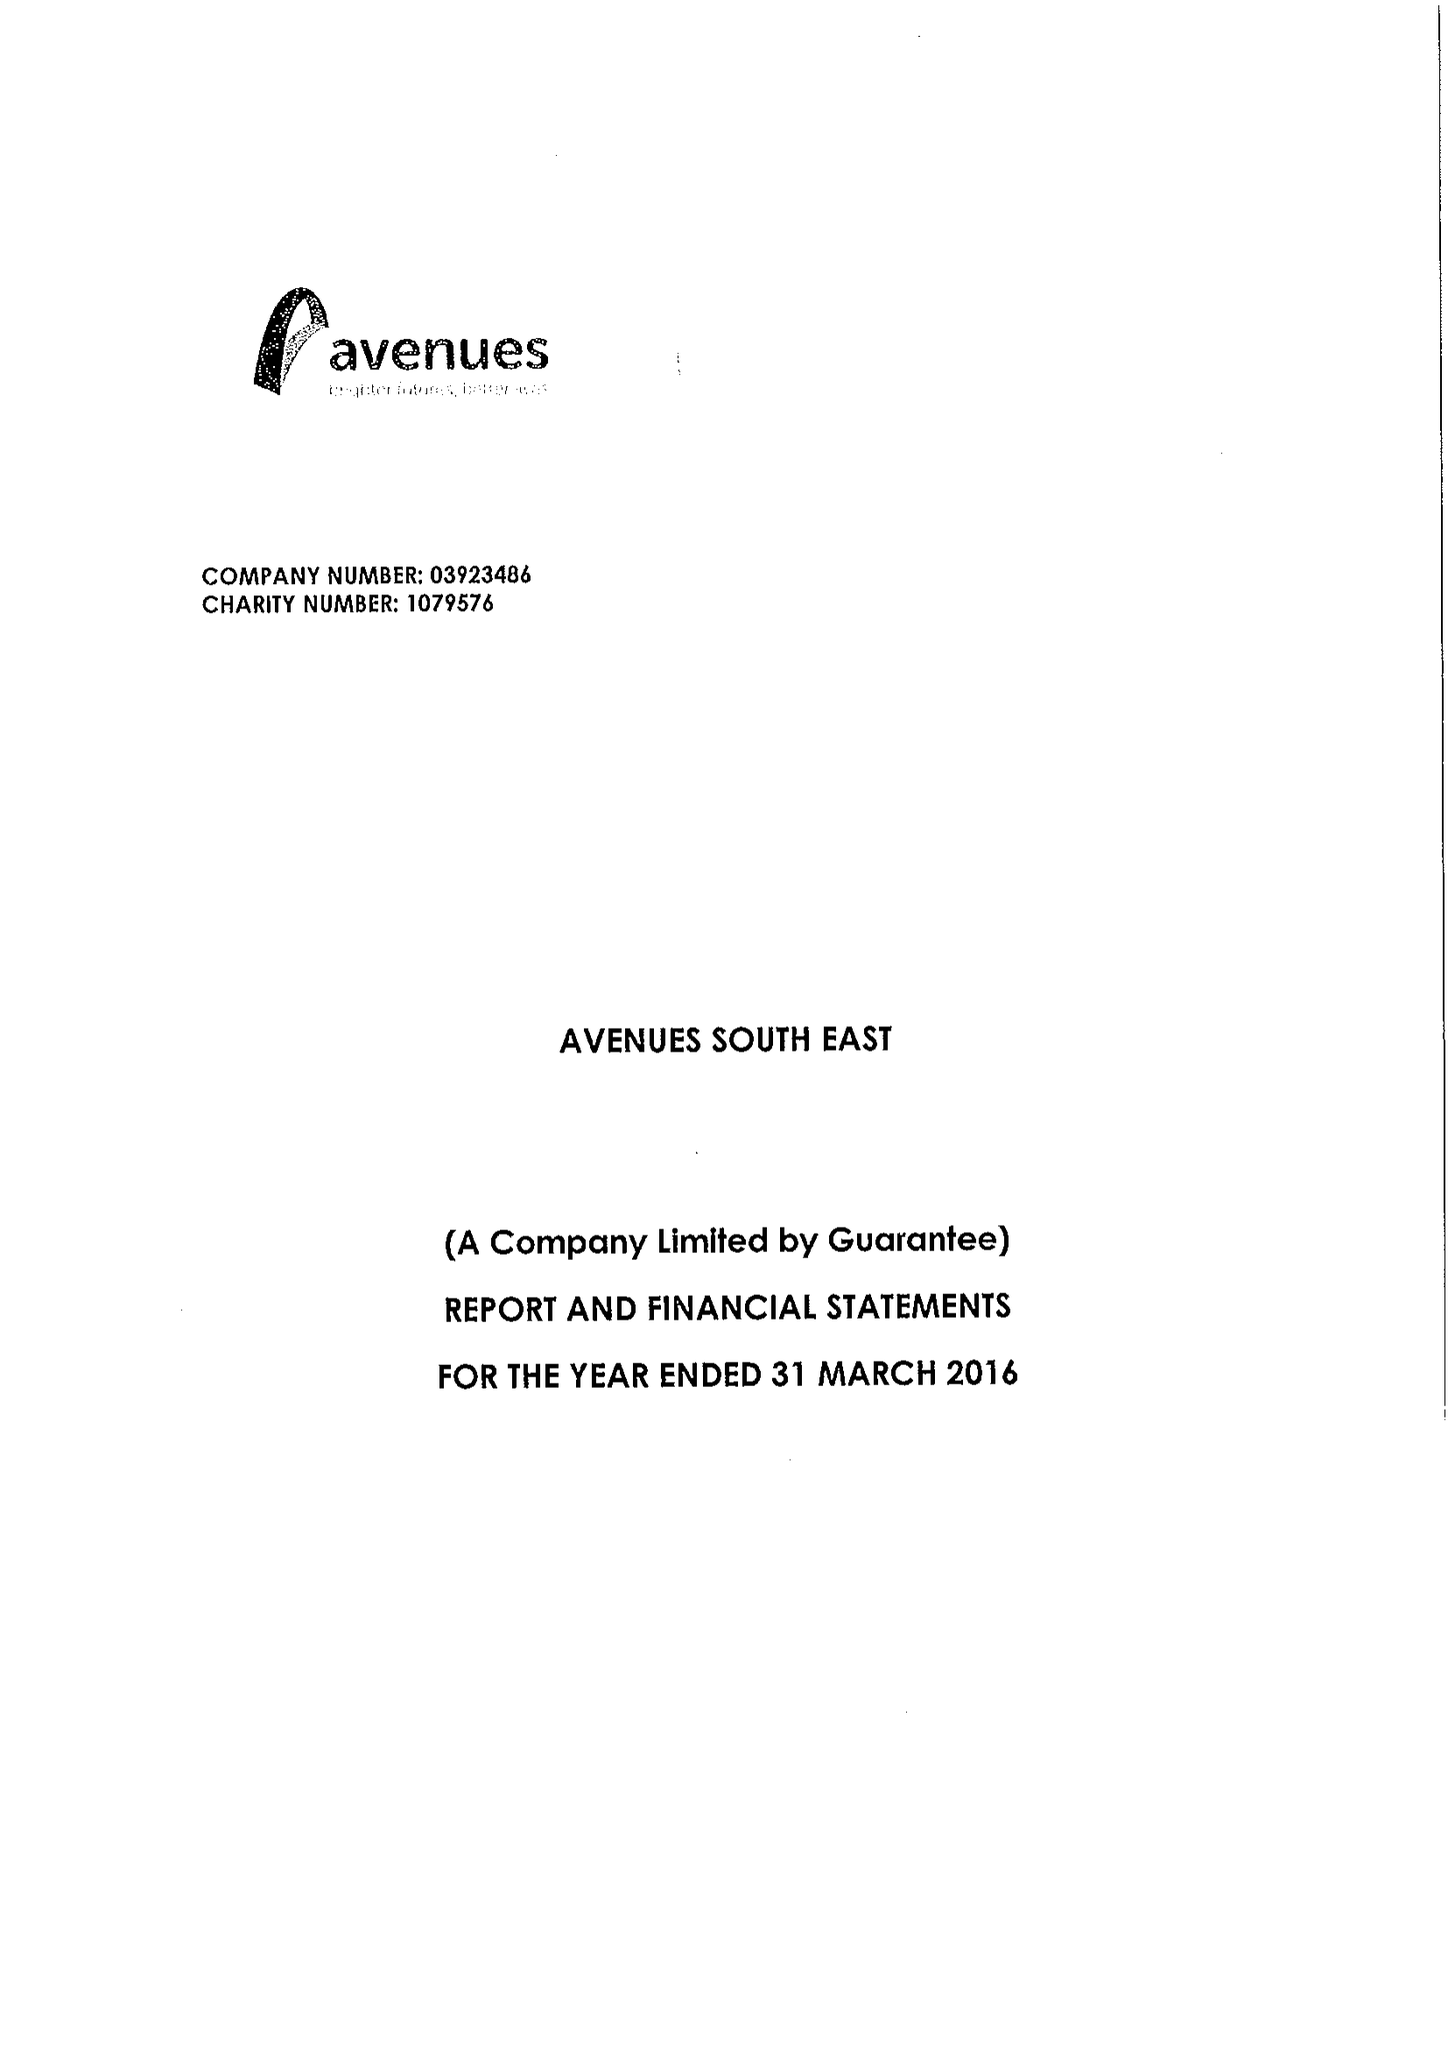What is the value for the charity_number?
Answer the question using a single word or phrase. 1079576 